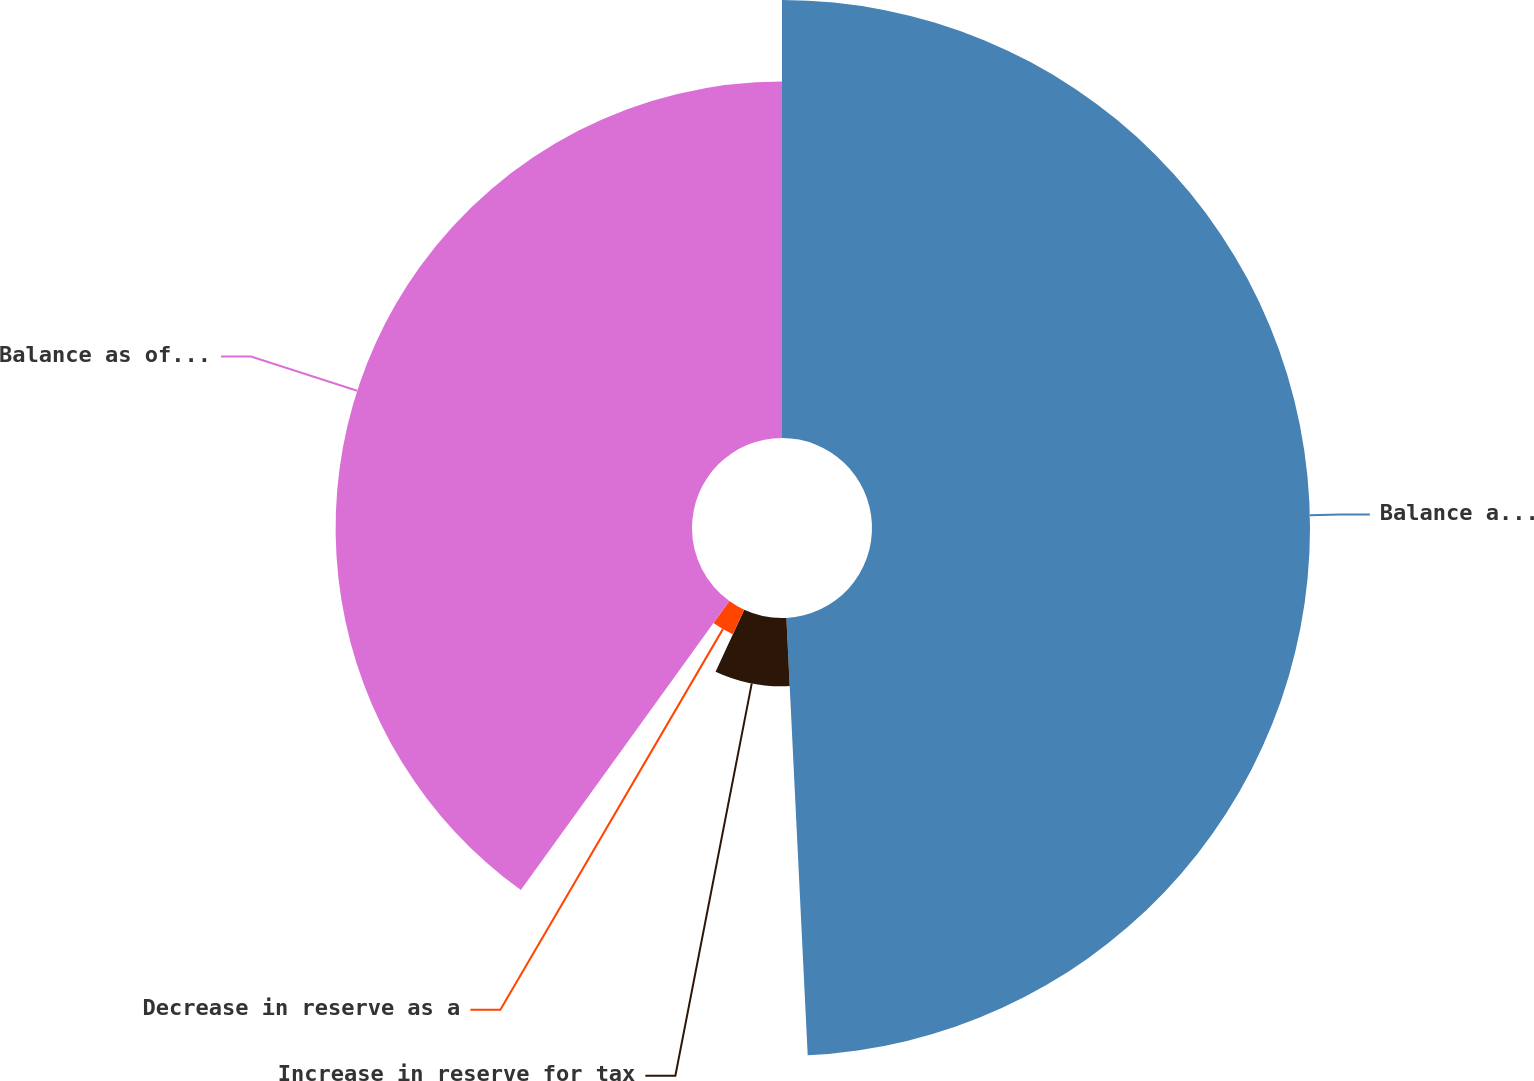<chart> <loc_0><loc_0><loc_500><loc_500><pie_chart><fcel>Balance as of January 1<fcel>Increase in reserve for tax<fcel>Decrease in reserve as a<fcel>Balance as of December 31<nl><fcel>49.22%<fcel>7.67%<fcel>3.05%<fcel>40.05%<nl></chart> 